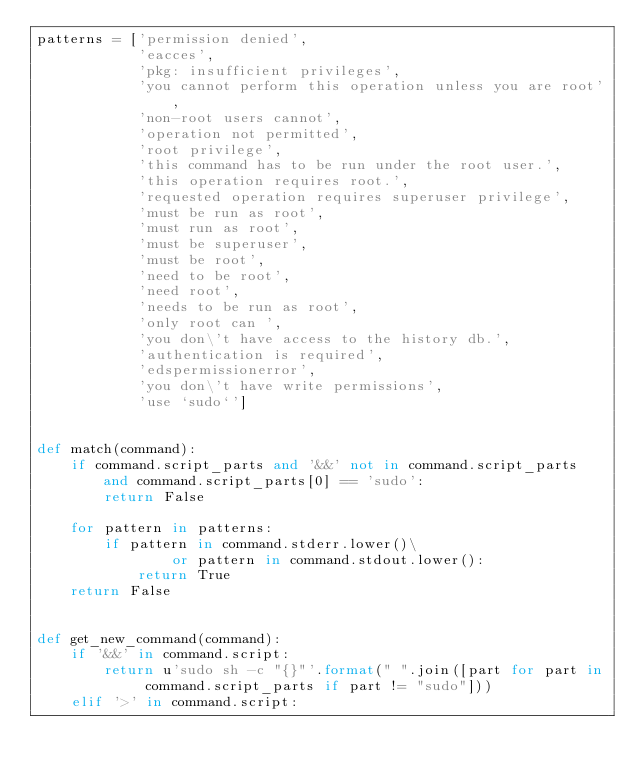Convert code to text. <code><loc_0><loc_0><loc_500><loc_500><_Python_>patterns = ['permission denied',
            'eacces',
            'pkg: insufficient privileges',
            'you cannot perform this operation unless you are root',
            'non-root users cannot',
            'operation not permitted',
            'root privilege',
            'this command has to be run under the root user.',
            'this operation requires root.',
            'requested operation requires superuser privilege',
            'must be run as root',
            'must run as root',
            'must be superuser',
            'must be root',
            'need to be root',
            'need root',
            'needs to be run as root',
            'only root can ',
            'you don\'t have access to the history db.',
            'authentication is required',
            'edspermissionerror',
            'you don\'t have write permissions',
            'use `sudo`']


def match(command):
    if command.script_parts and '&&' not in command.script_parts and command.script_parts[0] == 'sudo':
        return False

    for pattern in patterns:
        if pattern in command.stderr.lower()\
                or pattern in command.stdout.lower():
            return True
    return False


def get_new_command(command):
    if '&&' in command.script:
        return u'sudo sh -c "{}"'.format(" ".join([part for part in command.script_parts if part != "sudo"]))
    elif '>' in command.script:</code> 